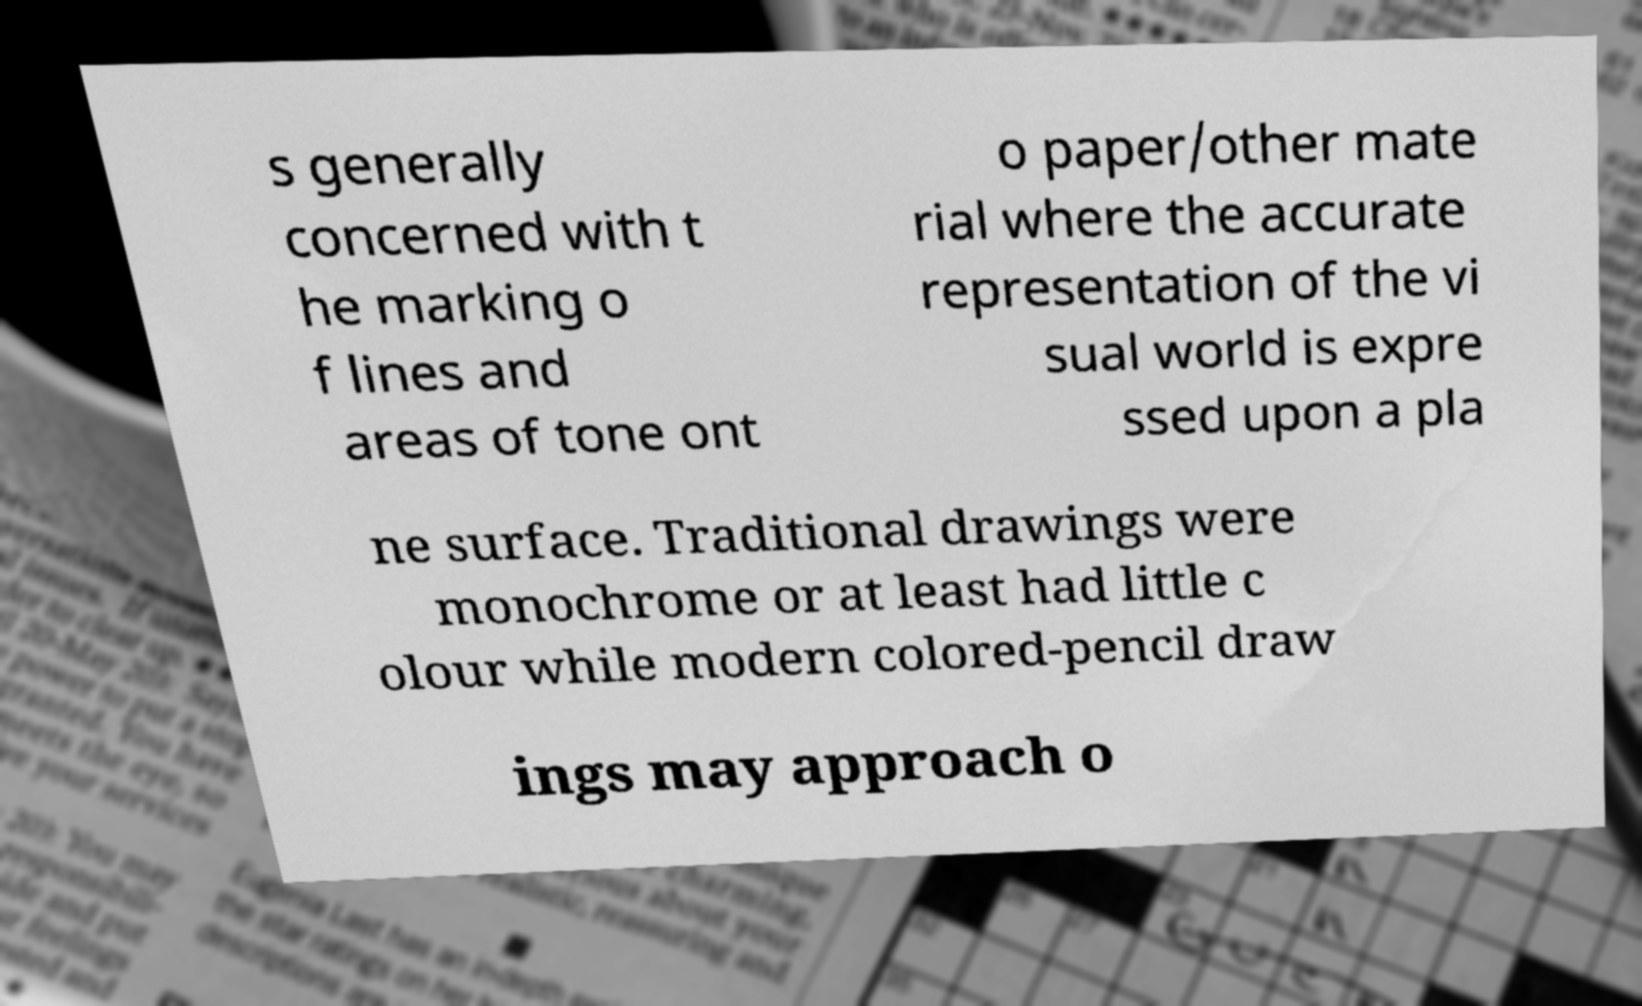Please identify and transcribe the text found in this image. s generally concerned with t he marking o f lines and areas of tone ont o paper/other mate rial where the accurate representation of the vi sual world is expre ssed upon a pla ne surface. Traditional drawings were monochrome or at least had little c olour while modern colored-pencil draw ings may approach o 